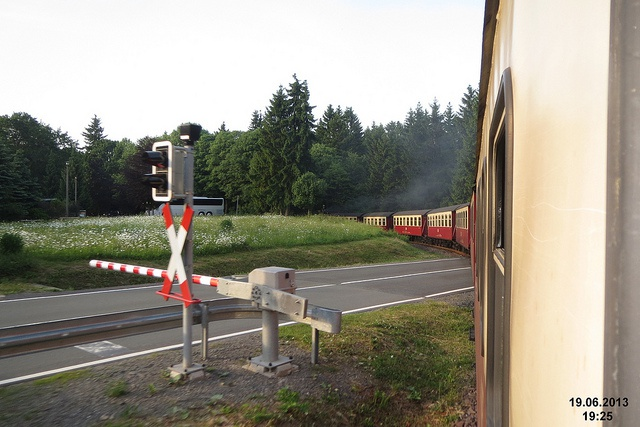Describe the objects in this image and their specific colors. I can see train in white, ivory, tan, and gray tones, traffic light in white, black, ivory, gray, and darkgray tones, and bus in white, black, gray, and darkgray tones in this image. 